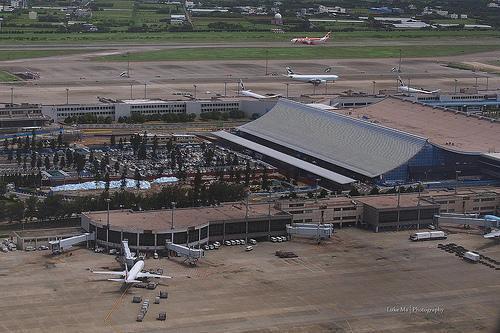How many planes are there?
Give a very brief answer. 5. How many airplanes are flying to the sky?
Give a very brief answer. 0. 